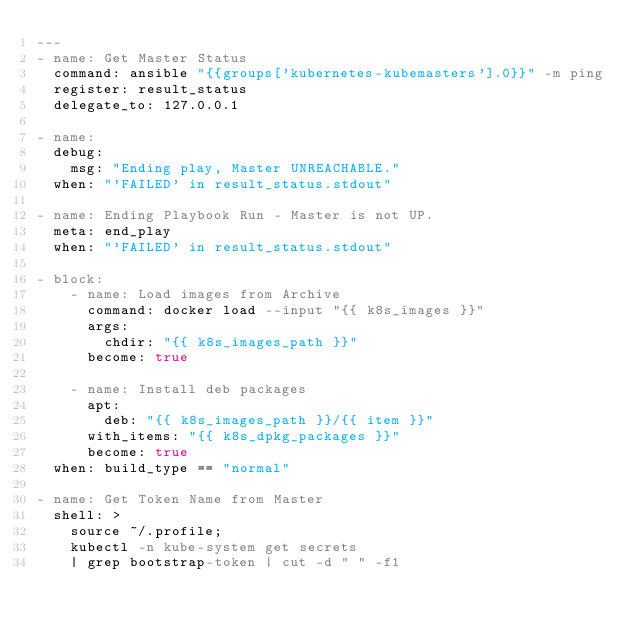Convert code to text. <code><loc_0><loc_0><loc_500><loc_500><_YAML_>---
- name: Get Master Status
  command: ansible "{{groups['kubernetes-kubemasters'].0}}" -m ping
  register: result_status
  delegate_to: 127.0.0.1

- name: 
  debug:
    msg: "Ending play, Master UNREACHABLE."
  when: "'FAILED' in result_status.stdout"

- name: Ending Playbook Run - Master is not UP.
  meta: end_play
  when: "'FAILED' in result_status.stdout"

- block:
    - name: Load images from Archive
      command: docker load --input "{{ k8s_images }}"
      args:
        chdir: "{{ k8s_images_path }}"
      become: true

    - name: Install deb packages
      apt:
        deb: "{{ k8s_images_path }}/{{ item }}"
      with_items: "{{ k8s_dpkg_packages }}"
      become: true
  when: build_type == "normal"

- name: Get Token Name from Master
  shell: >
    source ~/.profile;
    kubectl -n kube-system get secrets
    | grep bootstrap-token | cut -d " " -f1</code> 